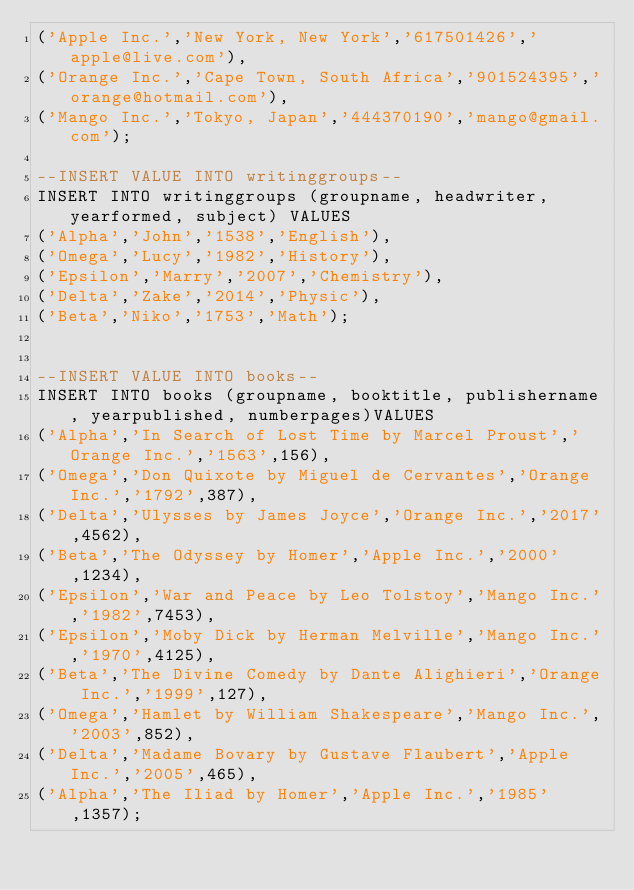<code> <loc_0><loc_0><loc_500><loc_500><_SQL_>('Apple Inc.','New York, New York','617501426','apple@live.com'),
('Orange Inc.','Cape Town, South Africa','901524395','orange@hotmail.com'),
('Mango Inc.','Tokyo, Japan','444370190','mango@gmail.com');

--INSERT VALUE INTO writinggroups--
INSERT INTO writinggroups (groupname, headwriter, yearformed, subject) VALUES 
('Alpha','John','1538','English'),
('Omega','Lucy','1982','History'),
('Epsilon','Marry','2007','Chemistry'),
('Delta','Zake','2014','Physic'),
('Beta','Niko','1753','Math');


--INSERT VALUE INTO books--
INSERT INTO books (groupname, booktitle, publishername, yearpublished, numberpages)VALUES 
('Alpha','In Search of Lost Time by Marcel Proust','Orange Inc.','1563',156),
('Omega','Don Quixote by Miguel de Cervantes','Orange Inc.','1792',387),
('Delta','Ulysses by James Joyce','Orange Inc.','2017',4562),
('Beta','The Odyssey by Homer','Apple Inc.','2000',1234),
('Epsilon','War and Peace by Leo Tolstoy','Mango Inc.','1982',7453),
('Epsilon','Moby Dick by Herman Melville','Mango Inc.','1970',4125),
('Beta','The Divine Comedy by Dante Alighieri','Orange Inc.','1999',127),
('Omega','Hamlet by William Shakespeare','Mango Inc.','2003',852),
('Delta','Madame Bovary by Gustave Flaubert','Apple Inc.','2005',465),
('Alpha','The Iliad by Homer','Apple Inc.','1985',1357);</code> 